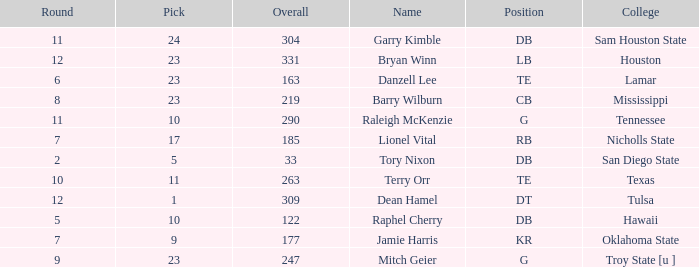Which Round is the highest one that has a Pick smaller than 10, and a Name of tory nixon? 2.0. 